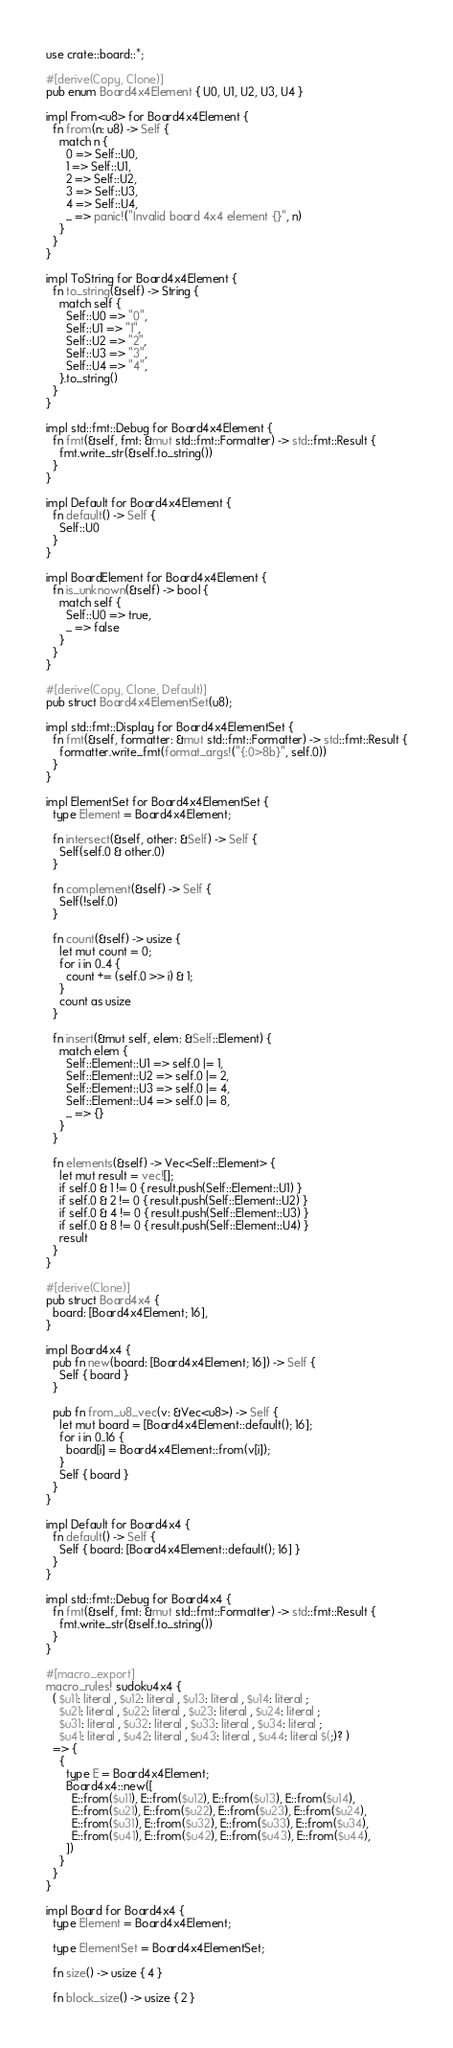Convert code to text. <code><loc_0><loc_0><loc_500><loc_500><_Rust_>use crate::board::*;

#[derive(Copy, Clone)]
pub enum Board4x4Element { U0, U1, U2, U3, U4 }

impl From<u8> for Board4x4Element {
  fn from(n: u8) -> Self {
    match n {
      0 => Self::U0,
      1 => Self::U1,
      2 => Self::U2,
      3 => Self::U3,
      4 => Self::U4,
      _ => panic!("Invalid board 4x4 element {}", n)
    }
  }
}

impl ToString for Board4x4Element {
  fn to_string(&self) -> String {
    match self {
      Self::U0 => "0",
      Self::U1 => "1",
      Self::U2 => "2",
      Self::U3 => "3",
      Self::U4 => "4",
    }.to_string()
  }
}

impl std::fmt::Debug for Board4x4Element {
  fn fmt(&self, fmt: &mut std::fmt::Formatter) -> std::fmt::Result {
    fmt.write_str(&self.to_string())
  }
}

impl Default for Board4x4Element {
  fn default() -> Self {
    Self::U0
  }
}

impl BoardElement for Board4x4Element {
  fn is_unknown(&self) -> bool {
    match self {
      Self::U0 => true,
      _ => false
    }
  }
}

#[derive(Copy, Clone, Default)]
pub struct Board4x4ElementSet(u8);

impl std::fmt::Display for Board4x4ElementSet {
  fn fmt(&self, formatter: &mut std::fmt::Formatter) -> std::fmt::Result {
    formatter.write_fmt(format_args!("{:0>8b}", self.0))
  }
}

impl ElementSet for Board4x4ElementSet {
  type Element = Board4x4Element;

  fn intersect(&self, other: &Self) -> Self {
    Self(self.0 & other.0)
  }

  fn complement(&self) -> Self {
    Self(!self.0)
  }

  fn count(&self) -> usize {
    let mut count = 0;
    for i in 0..4 {
      count += (self.0 >> i) & 1;
    }
    count as usize
  }

  fn insert(&mut self, elem: &Self::Element) {
    match elem {
      Self::Element::U1 => self.0 |= 1,
      Self::Element::U2 => self.0 |= 2,
      Self::Element::U3 => self.0 |= 4,
      Self::Element::U4 => self.0 |= 8,
      _ => {}
    }
  }

  fn elements(&self) -> Vec<Self::Element> {
    let mut result = vec![];
    if self.0 & 1 != 0 { result.push(Self::Element::U1) }
    if self.0 & 2 != 0 { result.push(Self::Element::U2) }
    if self.0 & 4 != 0 { result.push(Self::Element::U3) }
    if self.0 & 8 != 0 { result.push(Self::Element::U4) }
    result
  }
}

#[derive(Clone)]
pub struct Board4x4 {
  board: [Board4x4Element; 16],
}

impl Board4x4 {
  pub fn new(board: [Board4x4Element; 16]) -> Self {
    Self { board }
  }

  pub fn from_u8_vec(v: &Vec<u8>) -> Self {
    let mut board = [Board4x4Element::default(); 16];
    for i in 0..16 {
      board[i] = Board4x4Element::from(v[i]);
    }
    Self { board }
  }
}

impl Default for Board4x4 {
  fn default() -> Self {
    Self { board: [Board4x4Element::default(); 16] }
  }
}

impl std::fmt::Debug for Board4x4 {
  fn fmt(&self, fmt: &mut std::fmt::Formatter) -> std::fmt::Result {
    fmt.write_str(&self.to_string())
  }
}

#[macro_export]
macro_rules! sudoku4x4 {
  ( $u11: literal , $u12: literal , $u13: literal , $u14: literal ;
    $u21: literal , $u22: literal , $u23: literal , $u24: literal ;
    $u31: literal , $u32: literal , $u33: literal , $u34: literal ;
    $u41: literal , $u42: literal , $u43: literal , $u44: literal $(;)? )
  => {
    {
      type E = Board4x4Element;
      Board4x4::new([
        E::from($u11), E::from($u12), E::from($u13), E::from($u14),
        E::from($u21), E::from($u22), E::from($u23), E::from($u24),
        E::from($u31), E::from($u32), E::from($u33), E::from($u34),
        E::from($u41), E::from($u42), E::from($u43), E::from($u44),
      ])
    }
  }
}

impl Board for Board4x4 {
  type Element = Board4x4Element;

  type ElementSet = Board4x4ElementSet;

  fn size() -> usize { 4 }

  fn block_size() -> usize { 2 }
</code> 